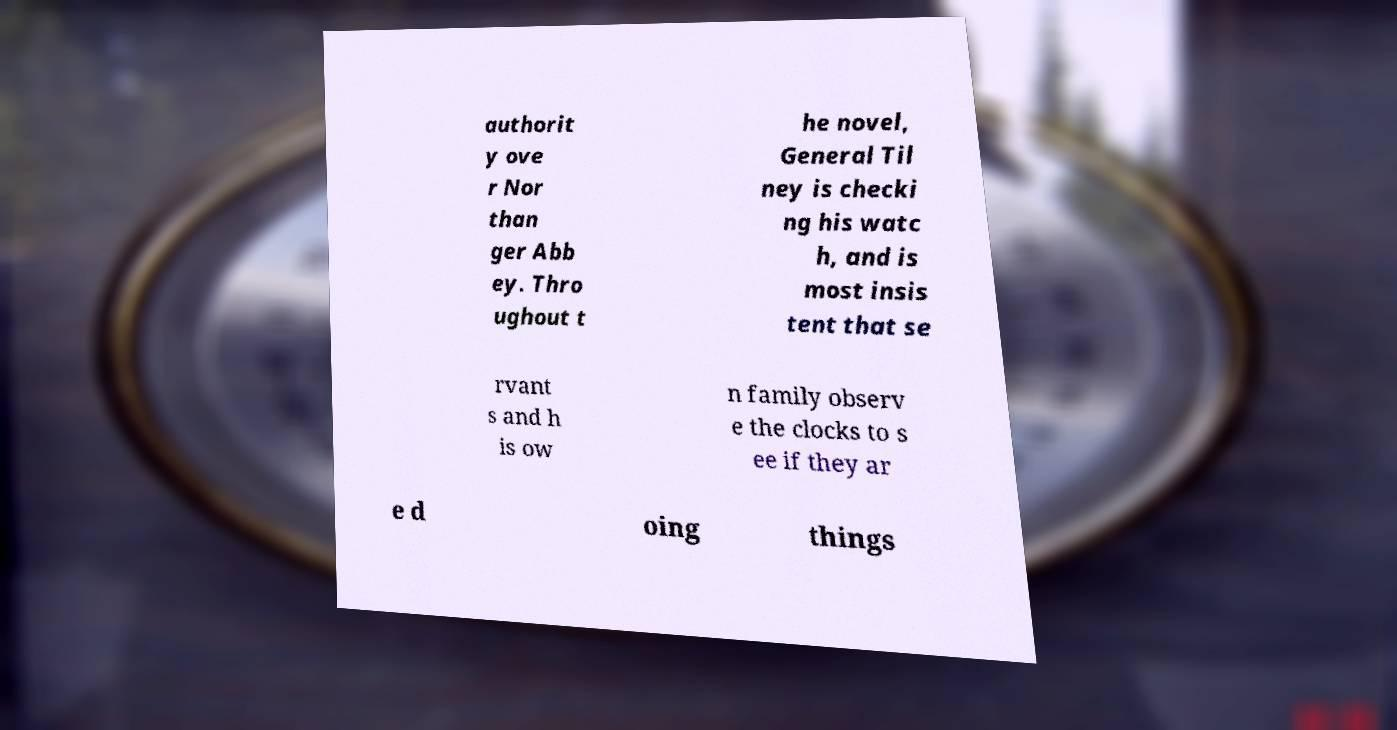Could you assist in decoding the text presented in this image and type it out clearly? authorit y ove r Nor than ger Abb ey. Thro ughout t he novel, General Til ney is checki ng his watc h, and is most insis tent that se rvant s and h is ow n family observ e the clocks to s ee if they ar e d oing things 